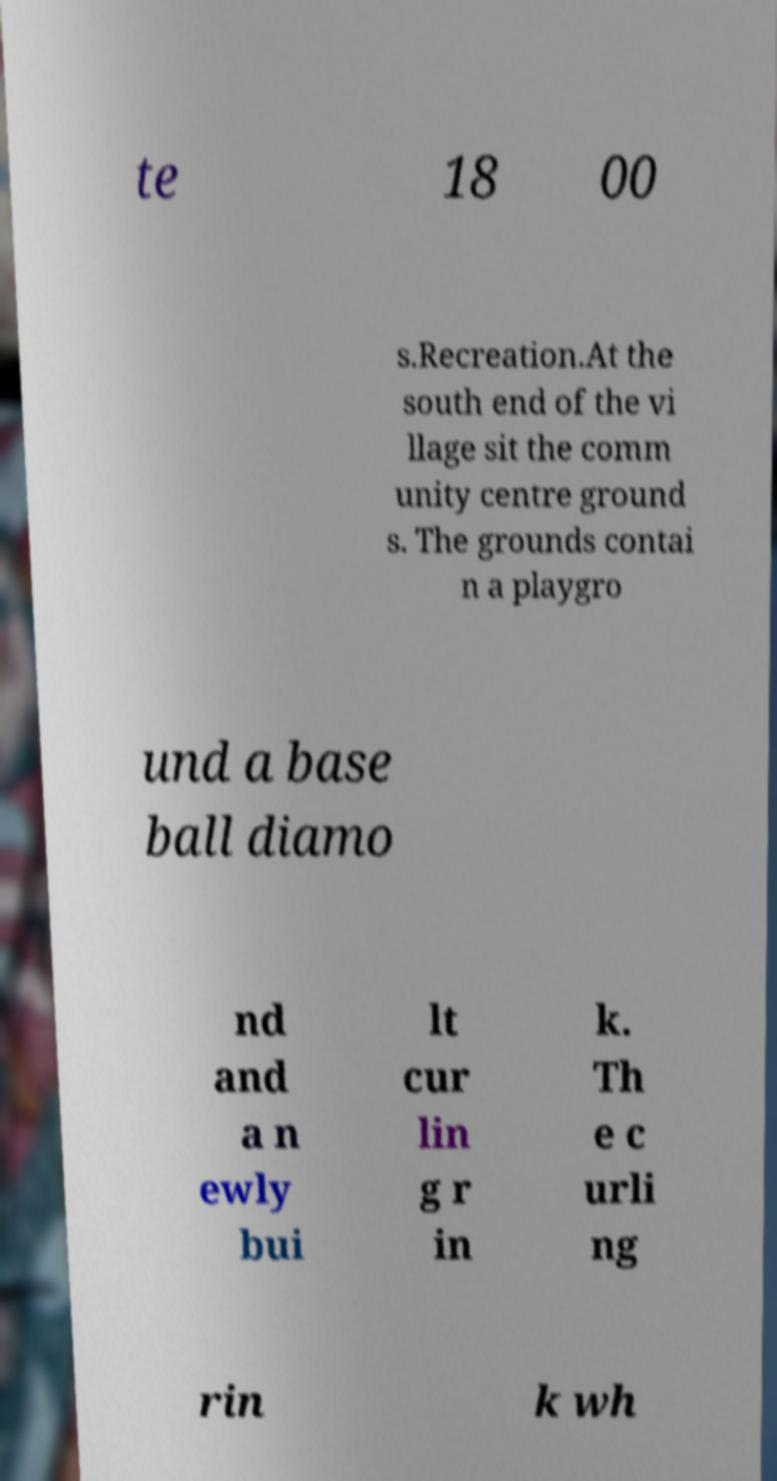What messages or text are displayed in this image? I need them in a readable, typed format. te 18 00 s.Recreation.At the south end of the vi llage sit the comm unity centre ground s. The grounds contai n a playgro und a base ball diamo nd and a n ewly bui lt cur lin g r in k. Th e c urli ng rin k wh 